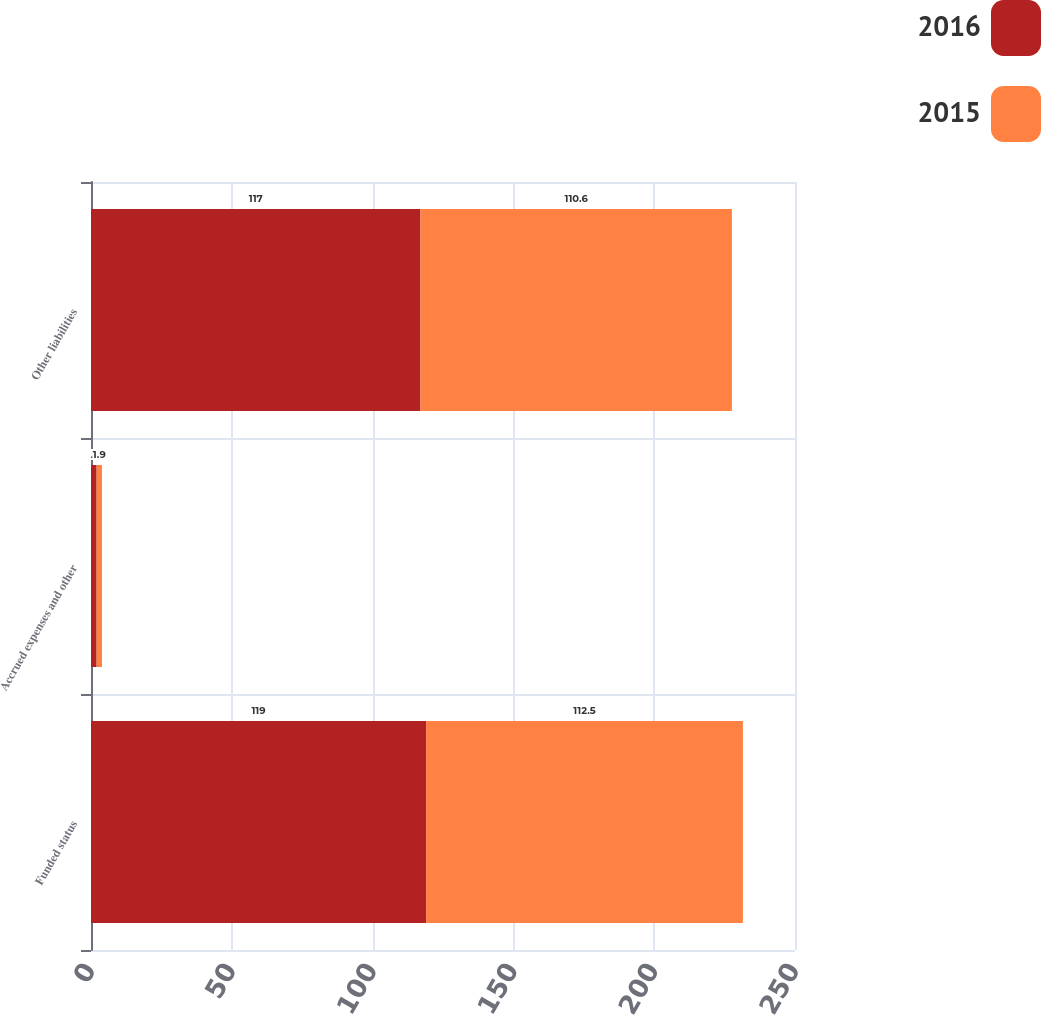<chart> <loc_0><loc_0><loc_500><loc_500><stacked_bar_chart><ecel><fcel>Funded status<fcel>Accrued expenses and other<fcel>Other liabilities<nl><fcel>2016<fcel>119<fcel>2<fcel>117<nl><fcel>2015<fcel>112.5<fcel>1.9<fcel>110.6<nl></chart> 